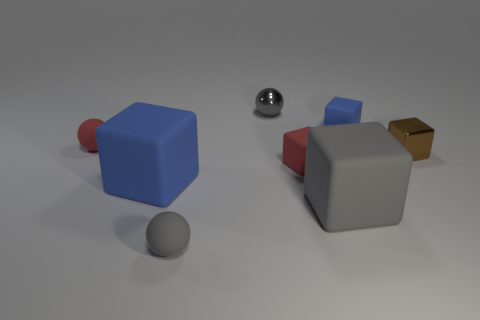The tiny metallic cube is what color?
Make the answer very short. Brown. There is a gray sphere behind the metal cube; what material is it?
Give a very brief answer. Metal. There is a gray matte object that is the same shape as the large blue object; what is its size?
Keep it short and to the point. Large. Are there fewer big blue rubber blocks that are to the right of the large blue matte thing than red balls?
Offer a very short reply. Yes. Are any gray cubes visible?
Offer a terse response. Yes. There is a metallic object that is the same shape as the small blue rubber object; what color is it?
Make the answer very short. Brown. There is a tiny matte sphere in front of the large gray rubber cube; does it have the same color as the tiny metal ball?
Offer a very short reply. Yes. Is the gray metallic ball the same size as the brown metal cube?
Keep it short and to the point. Yes. There is a small red thing that is made of the same material as the red block; what is its shape?
Give a very brief answer. Sphere. What number of other objects are there of the same shape as the tiny gray metal thing?
Ensure brevity in your answer.  2. 